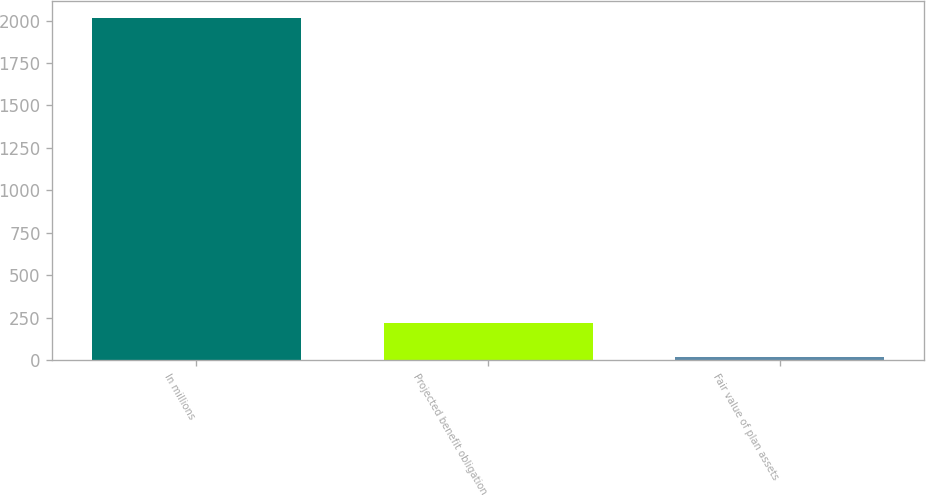<chart> <loc_0><loc_0><loc_500><loc_500><bar_chart><fcel>In millions<fcel>Projected benefit obligation<fcel>Fair value of plan assets<nl><fcel>2016<fcel>217.35<fcel>17.5<nl></chart> 